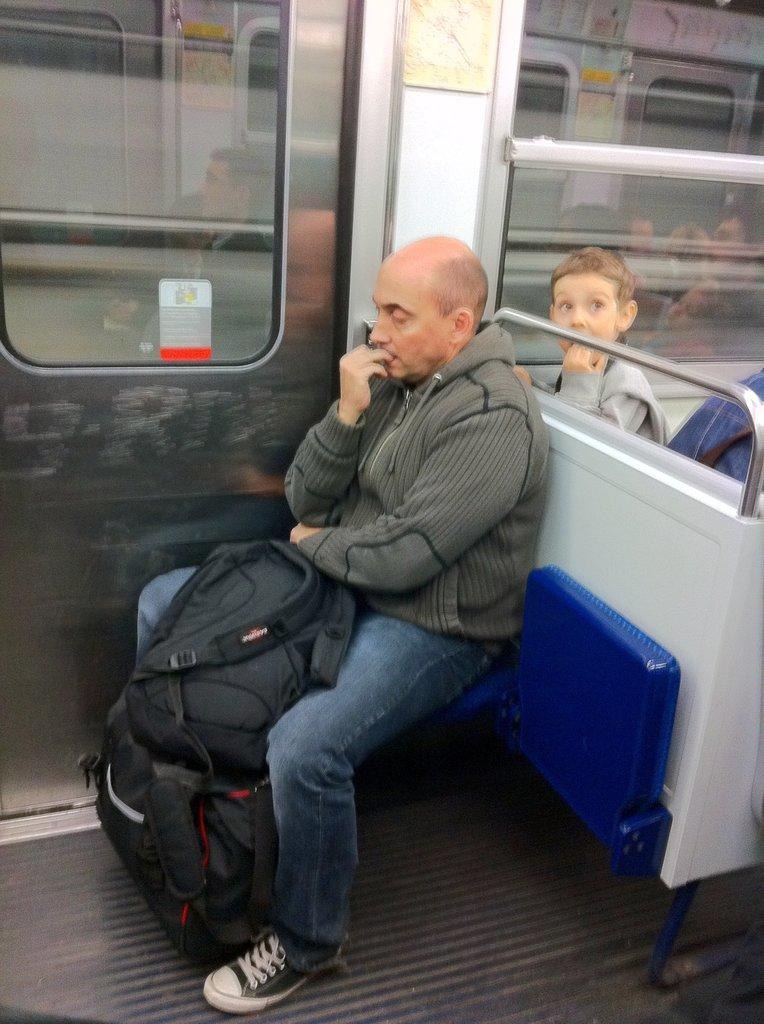What is the person in the image doing? The person is sitting in the image. What is the color of the seat the person is sitting on? The person is sitting on a blue color seat. What type of jacket is the person wearing? The person is wearing an ash jacket. What type of pants is the person wearing? The person is wearing jeans. What is the person holding in the image? The person is holding black color bags. What can be seen in the background of the image? There is a glass door visible in the background. What type of sweater is the owl wearing in the image? There is no owl present in the image, and therefore no sweater or any other clothing item for the owl. 